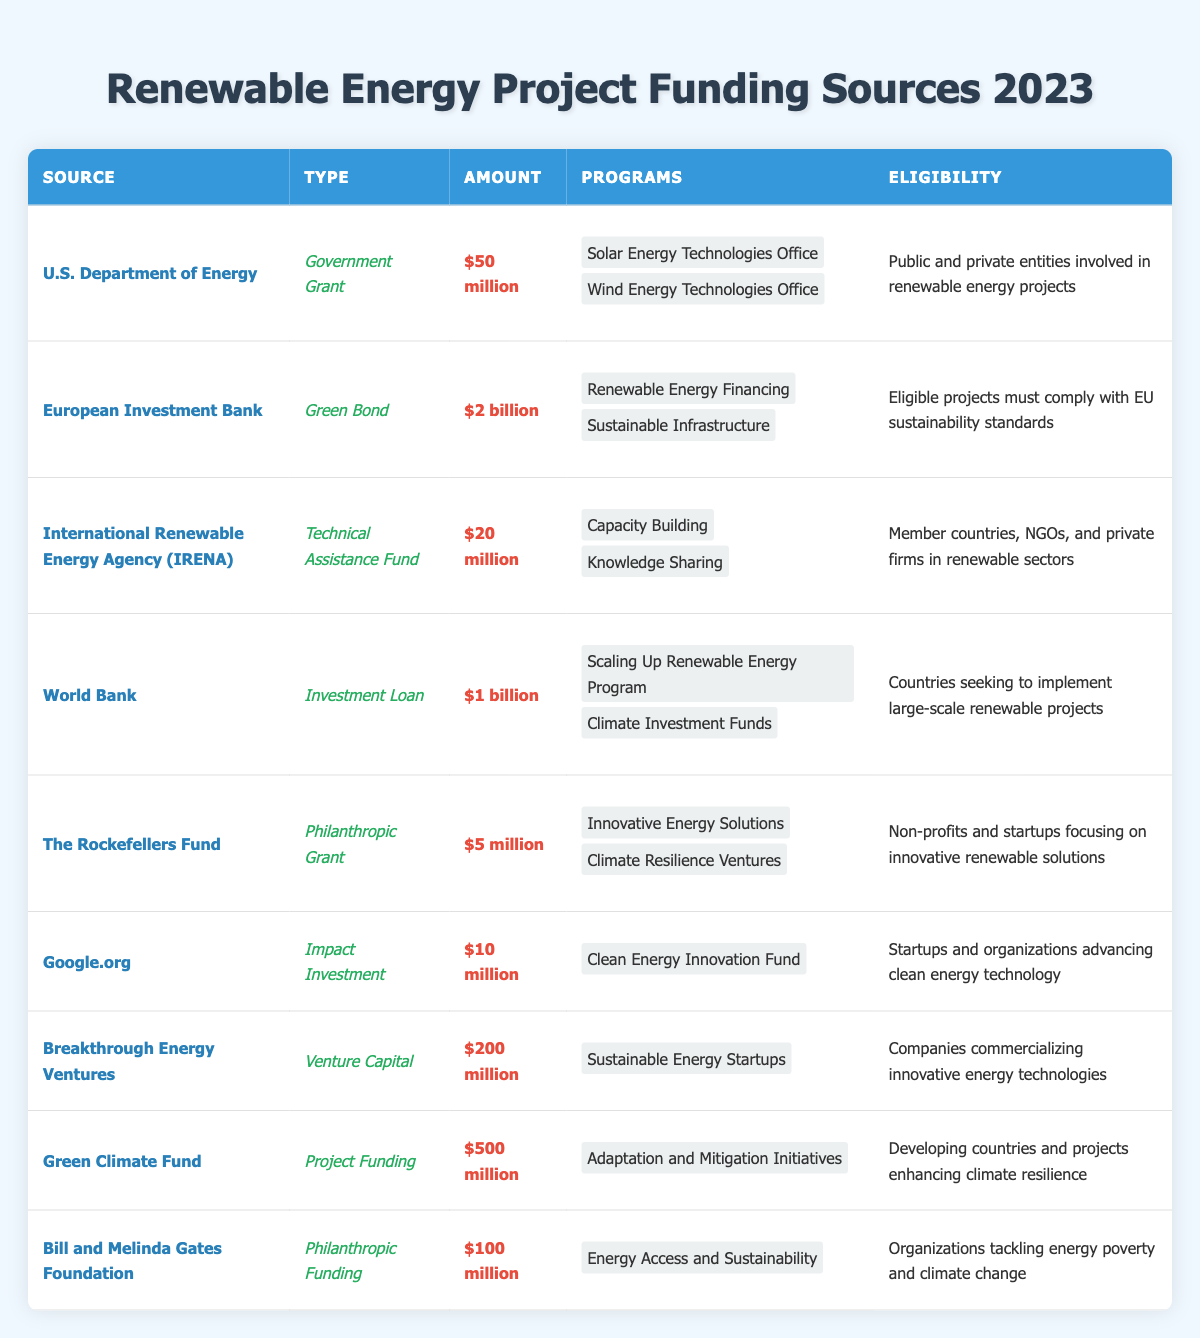What is the total amount of funding available from the U.S. Department of Energy? The table indicates that the U.S. Department of Energy has allocated $50 million for funding.
Answer: $50 million Which funding source provides the highest amount? The European Investment Bank offers the highest amount at $2 billion, as stated in the Amount column.
Answer: $2 billion Is there any source that offers exactly $10 million? The table shows that Google.org provides exactly $10 million in funding, confirming the question is true.
Answer: Yes How much more funding does Breakthrough Energy Ventures provide compared to The Rockefellers Fund? Breakthrough Energy Ventures offers $200 million while The Rockefellers Fund offers $5 million. The difference is $200 million - $5 million = $195 million.
Answer: $195 million How many funding sources have an amount greater than $100 million? The European Investment Bank ($2 billion), World Bank ($1 billion), Green Climate Fund ($500 million), and Bill and Melinda Gates Foundation ($100 million) meet this criterion. This totals four funding sources.
Answer: 4 Are all funding sources eligible for public and private entities? Eligibility details show that only the U.S. Department of Energy's funding is available to both public and private entities, while others have varied eligibility criteria.
Answer: No What is the average funding amount of all listed sources? Adding all the amounts: $50M + $2B + $20M + $1B + $5M + $10M + $200M + $500M + $100M = $3.885B. There are 9 sources, so the average is $3.885B / 9 = approximately $431.67 million.
Answer: Approximately $431.67 million Which organization provides funding specifically for startups focusing on innovative renewable solutions? The table states that The Rockefellers Fund is aimed at non-profits and startups focusing on innovative renewable solutions as listed in its eligibility criteria.
Answer: The Rockefellers Fund What type of funding does the European Investment Bank provide? The table indicates that the European Investment Bank provides funding through a Green Bond type.
Answer: Green Bond If a project is located in a developing country, which funding source could be applicable? According to the table, the Green Climate Fund specifies that it funds projects enhancing climate resilience in developing countries.
Answer: Green Climate Fund 